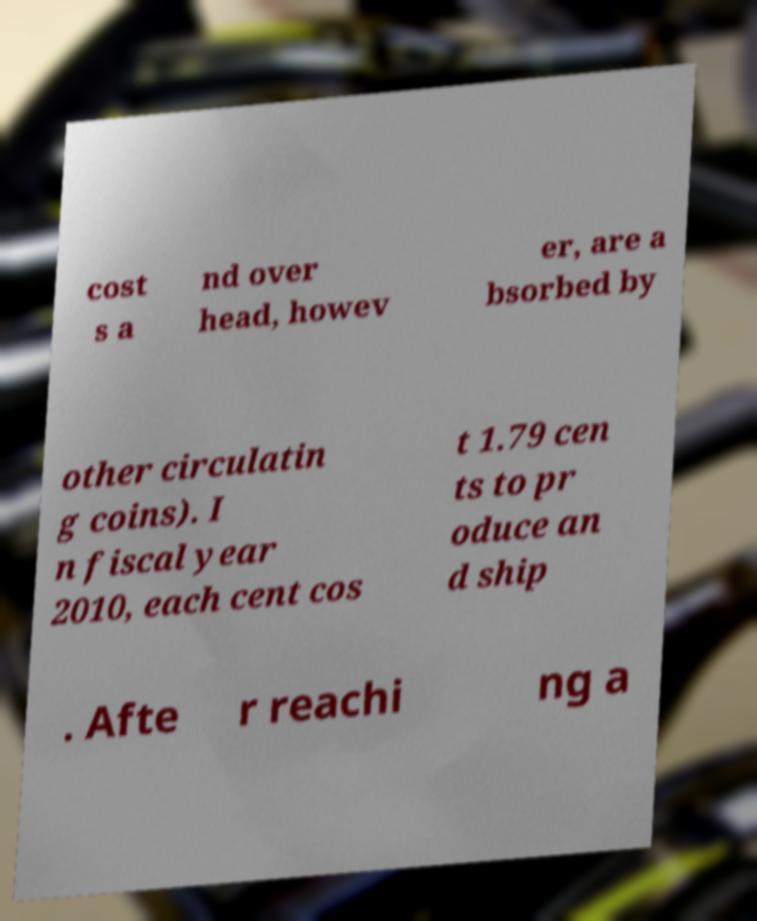Could you extract and type out the text from this image? cost s a nd over head, howev er, are a bsorbed by other circulatin g coins). I n fiscal year 2010, each cent cos t 1.79 cen ts to pr oduce an d ship . Afte r reachi ng a 